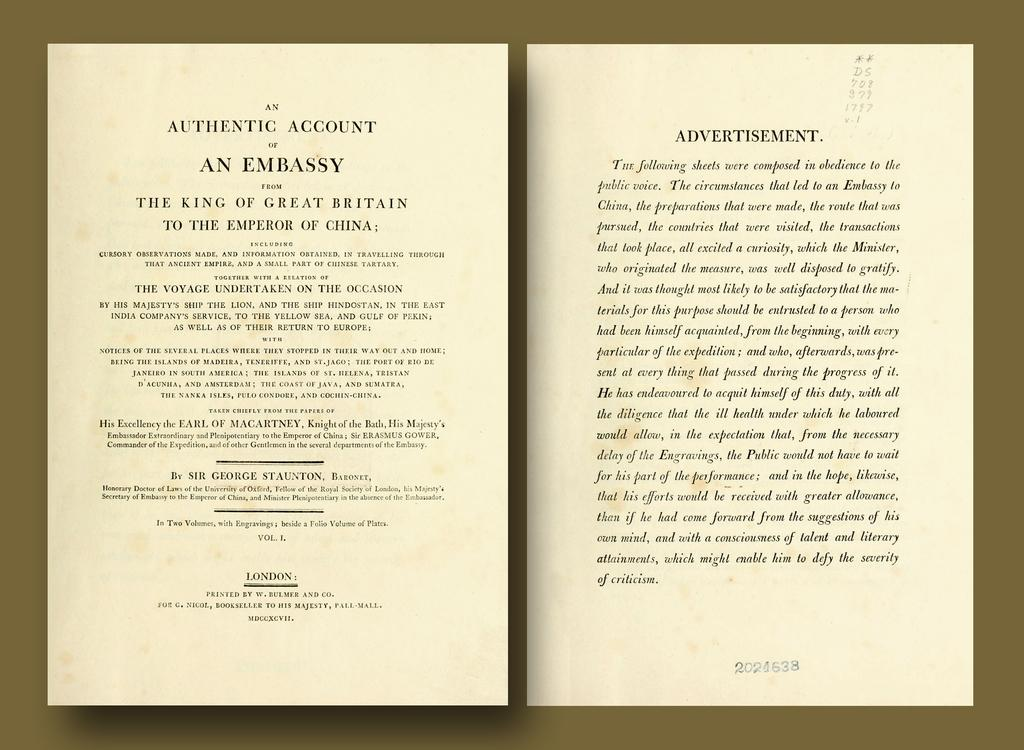<image>
Provide a brief description of the given image. An old book open to a page titled Authentic Account of an Embassy. 